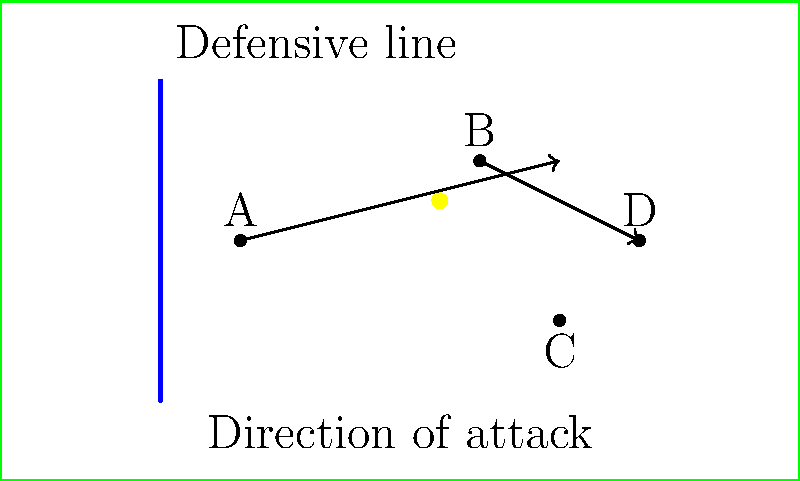In the diagram above, which player is in an offside position if player B passes the ball forward to player D? To determine if a player is in an offside position, we need to follow these steps:

1. Identify the second-last defender: In this case, the blue line represents the defensive line, which is the second-last defender.

2. Identify the ball's position: The ball is with player B.

3. Check the positions of the attacking players relative to the defensive line and the ball:
   - Player A is behind the defensive line and the ball, so they are not offside.
   - Player B has the ball, so they cannot be offside.
   - Player C is behind the defensive line, so they are not offside.
   - Player D is ahead of both the defensive line and the ball when B passes.

4. Apply the offside rule: A player is in an offside position if they are nearer to the opponents' goal line than both the ball and the second-last opponent when the ball is played by a teammate.

5. Conclusion: Player D is the only player in an offside position when B passes the ball forward.

The offside trap strategy relies on the defending team moving their defensive line forward at the right moment, leaving attacking players in offside positions. This diagram illustrates a successful execution of the offside trap, as player D would be called offside if they receive the ball from player B.
Answer: Player D 